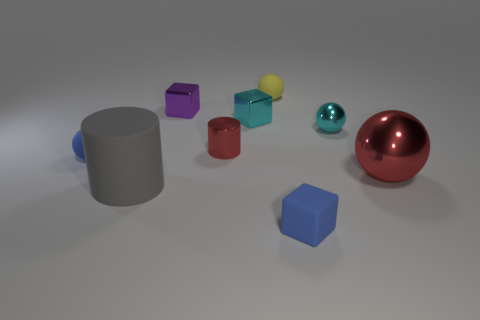There is a sphere that is the same color as the tiny matte cube; what material is it?
Give a very brief answer. Rubber. There is a metal cylinder that is the same color as the large ball; what is its size?
Offer a very short reply. Small. There is a matte cylinder; does it have the same size as the matte ball that is in front of the cyan cube?
Offer a terse response. No. There is a red metal thing that is in front of the red cylinder; what size is it?
Your answer should be compact. Large. What number of tiny matte things have the same color as the small matte cube?
Offer a terse response. 1. How many brown things are there?
Give a very brief answer. 0. There is a big object that is the same shape as the small yellow rubber thing; what material is it?
Your answer should be compact. Metal. Are there fewer small yellow objects in front of the yellow rubber thing than big yellow shiny balls?
Keep it short and to the point. No. There is a red metallic thing that is on the right side of the tiny yellow matte thing; does it have the same shape as the yellow thing?
Your response must be concise. Yes. Is there anything else that has the same color as the big cylinder?
Provide a succinct answer. No. 